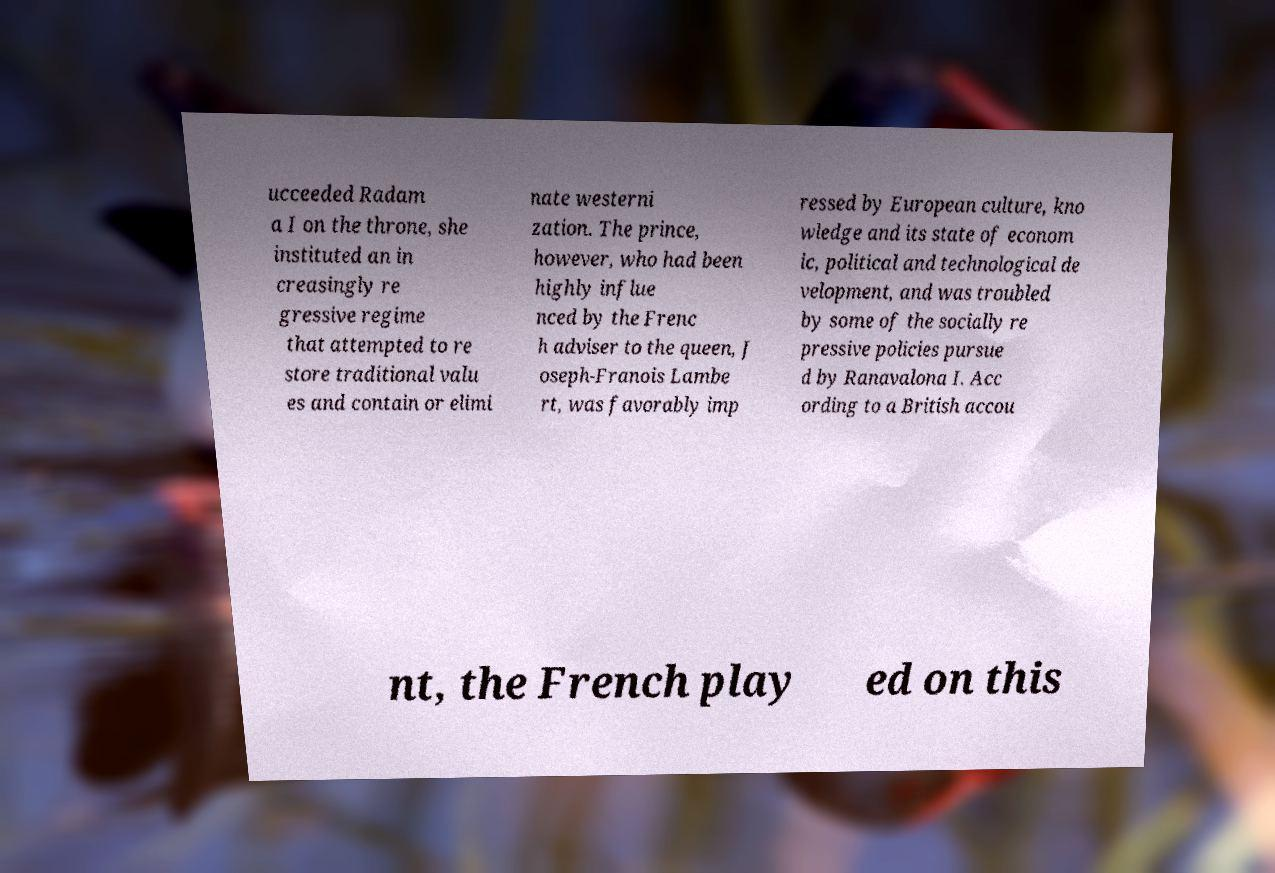Can you read and provide the text displayed in the image?This photo seems to have some interesting text. Can you extract and type it out for me? ucceeded Radam a I on the throne, she instituted an in creasingly re gressive regime that attempted to re store traditional valu es and contain or elimi nate westerni zation. The prince, however, who had been highly influe nced by the Frenc h adviser to the queen, J oseph-Franois Lambe rt, was favorably imp ressed by European culture, kno wledge and its state of econom ic, political and technological de velopment, and was troubled by some of the socially re pressive policies pursue d by Ranavalona I. Acc ording to a British accou nt, the French play ed on this 